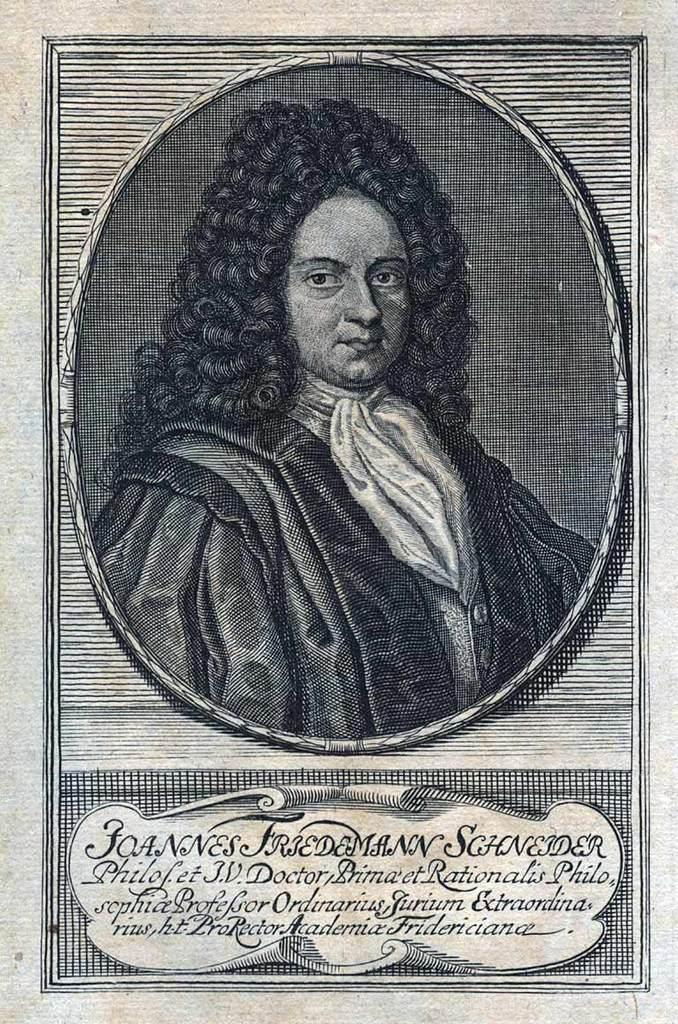What is the main object in the image? There is a poster in the image. What is depicted in the poster? The poster has a painting of a person. Are there any words or phrases on the poster? Yes, there are texts on the poster. What type of credit card is shown in the image? There is no credit card present in the image; it only features a poster with a painting of a person and texts. 